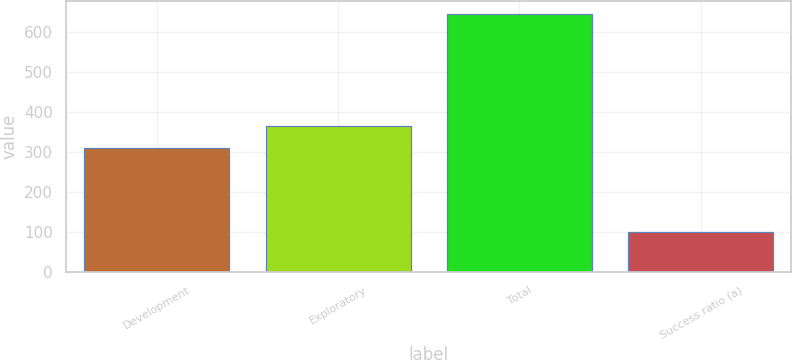Convert chart. <chart><loc_0><loc_0><loc_500><loc_500><bar_chart><fcel>Development<fcel>Exploratory<fcel>Total<fcel>Success ratio (a)<nl><fcel>309<fcel>363.5<fcel>644<fcel>99<nl></chart> 